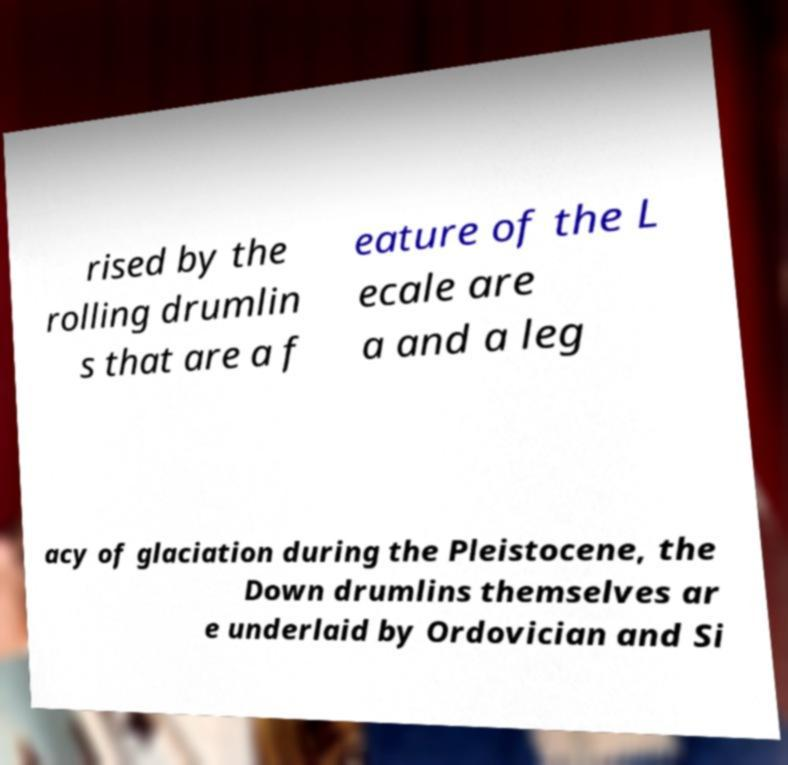There's text embedded in this image that I need extracted. Can you transcribe it verbatim? rised by the rolling drumlin s that are a f eature of the L ecale are a and a leg acy of glaciation during the Pleistocene, the Down drumlins themselves ar e underlaid by Ordovician and Si 